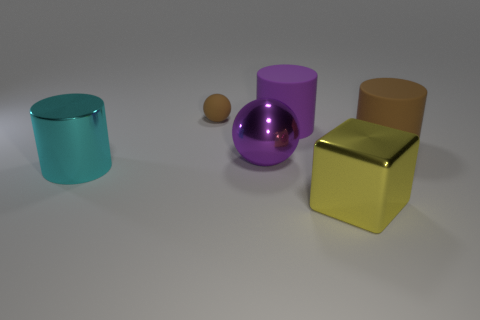There is a big yellow metal thing; is it the same shape as the large shiny thing that is behind the big metallic cylinder?
Keep it short and to the point. No. What number of other objects are the same material as the large brown cylinder?
Give a very brief answer. 2. Are there any big blocks left of the purple metal ball?
Provide a succinct answer. No. Does the cyan object have the same size as the purple object on the right side of the large purple sphere?
Ensure brevity in your answer.  Yes. There is a shiny object that is right of the matte cylinder that is to the left of the big metal cube; what is its color?
Your response must be concise. Yellow. Does the cyan metallic cylinder have the same size as the purple metallic sphere?
Your answer should be compact. Yes. What color is the shiny thing that is both on the right side of the cyan metal cylinder and behind the metal block?
Your answer should be very brief. Purple. What size is the metallic cylinder?
Make the answer very short. Large. Do the large thing that is in front of the cyan metal cylinder and the metallic cylinder have the same color?
Ensure brevity in your answer.  No. Are there more purple metal things right of the brown rubber cylinder than big cyan objects behind the cyan cylinder?
Provide a succinct answer. No. 